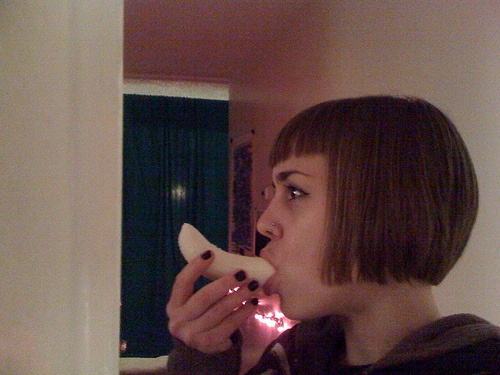Describe the objects in this image and their specific colors. I can see people in gray, black, maroon, and brown tones and banana in gray and maroon tones in this image. 